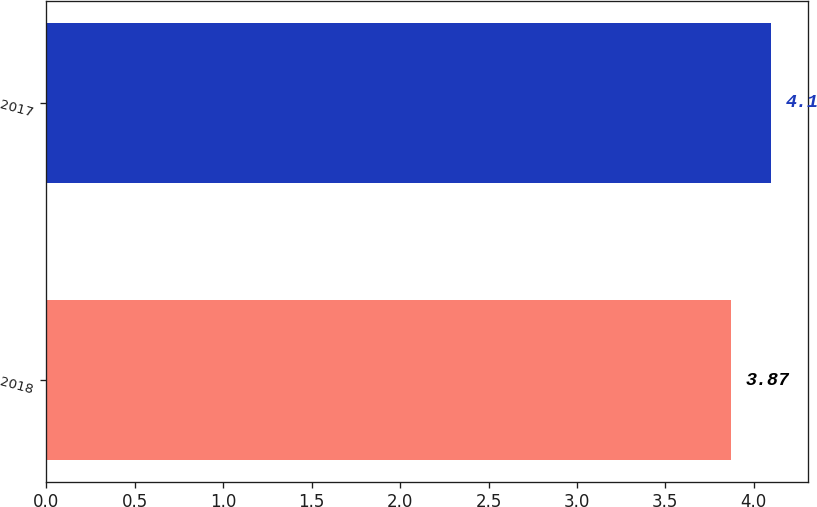Convert chart. <chart><loc_0><loc_0><loc_500><loc_500><bar_chart><fcel>2018<fcel>2017<nl><fcel>3.87<fcel>4.1<nl></chart> 